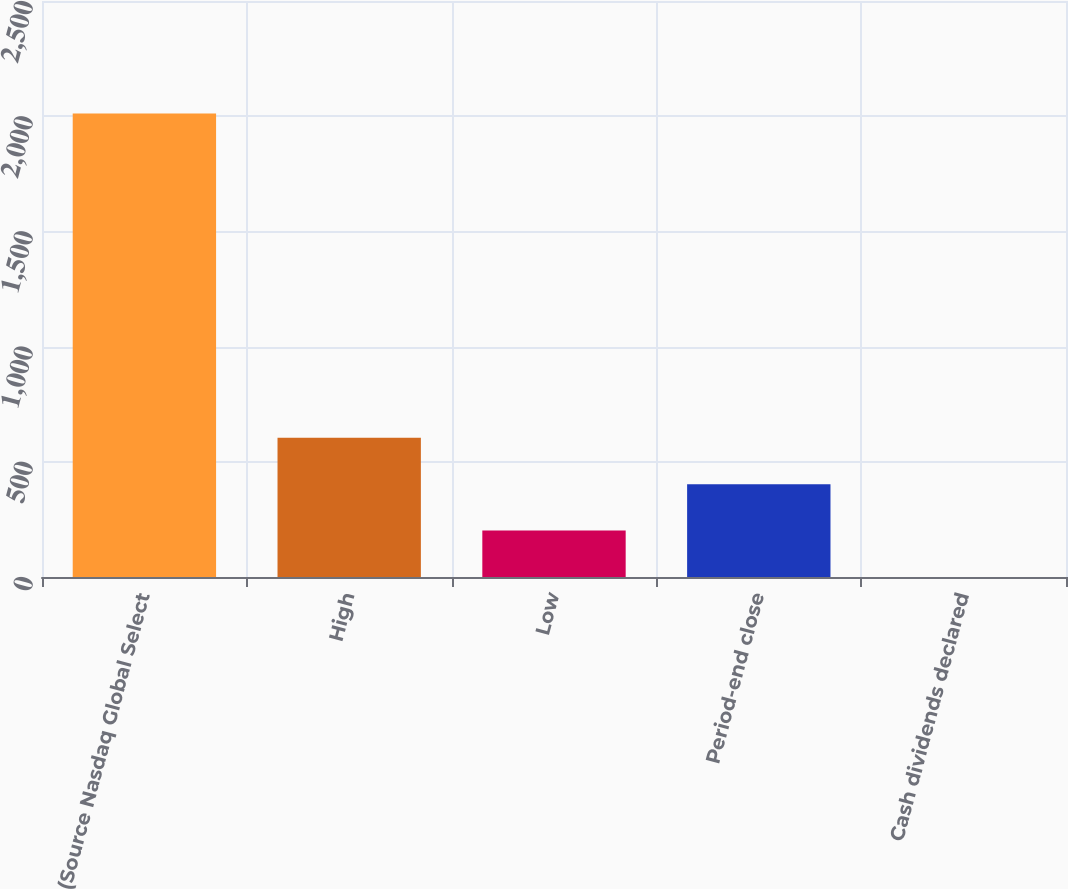<chart> <loc_0><loc_0><loc_500><loc_500><bar_chart><fcel>(Source Nasdaq Global Select<fcel>High<fcel>Low<fcel>Period-end close<fcel>Cash dividends declared<nl><fcel>2012<fcel>603.88<fcel>201.56<fcel>402.72<fcel>0.4<nl></chart> 